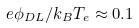<formula> <loc_0><loc_0><loc_500><loc_500>e \phi _ { D L } / k _ { B } T _ { e } \approx 0 . 1</formula> 